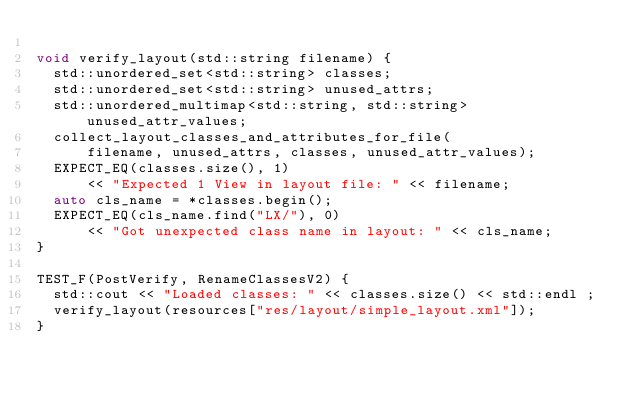<code> <loc_0><loc_0><loc_500><loc_500><_C++_>
void verify_layout(std::string filename) {
  std::unordered_set<std::string> classes;
  std::unordered_set<std::string> unused_attrs;
  std::unordered_multimap<std::string, std::string> unused_attr_values;
  collect_layout_classes_and_attributes_for_file(
      filename, unused_attrs, classes, unused_attr_values);
  EXPECT_EQ(classes.size(), 1)
      << "Expected 1 View in layout file: " << filename;
  auto cls_name = *classes.begin();
  EXPECT_EQ(cls_name.find("LX/"), 0)
      << "Got unexpected class name in layout: " << cls_name;
}

TEST_F(PostVerify, RenameClassesV2) {
  std::cout << "Loaded classes: " << classes.size() << std::endl ;
  verify_layout(resources["res/layout/simple_layout.xml"]);
}
</code> 